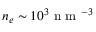Convert formula to latex. <formula><loc_0><loc_0><loc_500><loc_500>n _ { e } \sim 1 0 ^ { 3 } n m ^ { - 3 }</formula> 